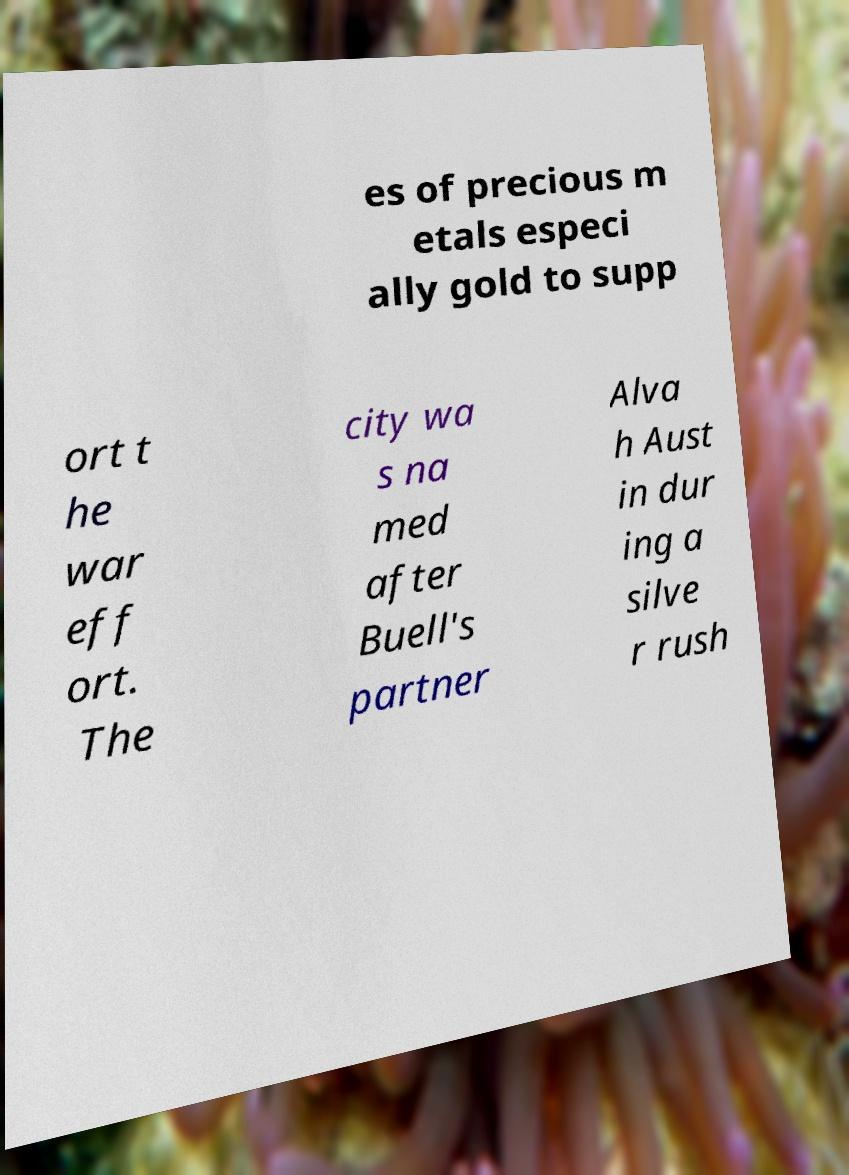I need the written content from this picture converted into text. Can you do that? es of precious m etals especi ally gold to supp ort t he war eff ort. The city wa s na med after Buell's partner Alva h Aust in dur ing a silve r rush 